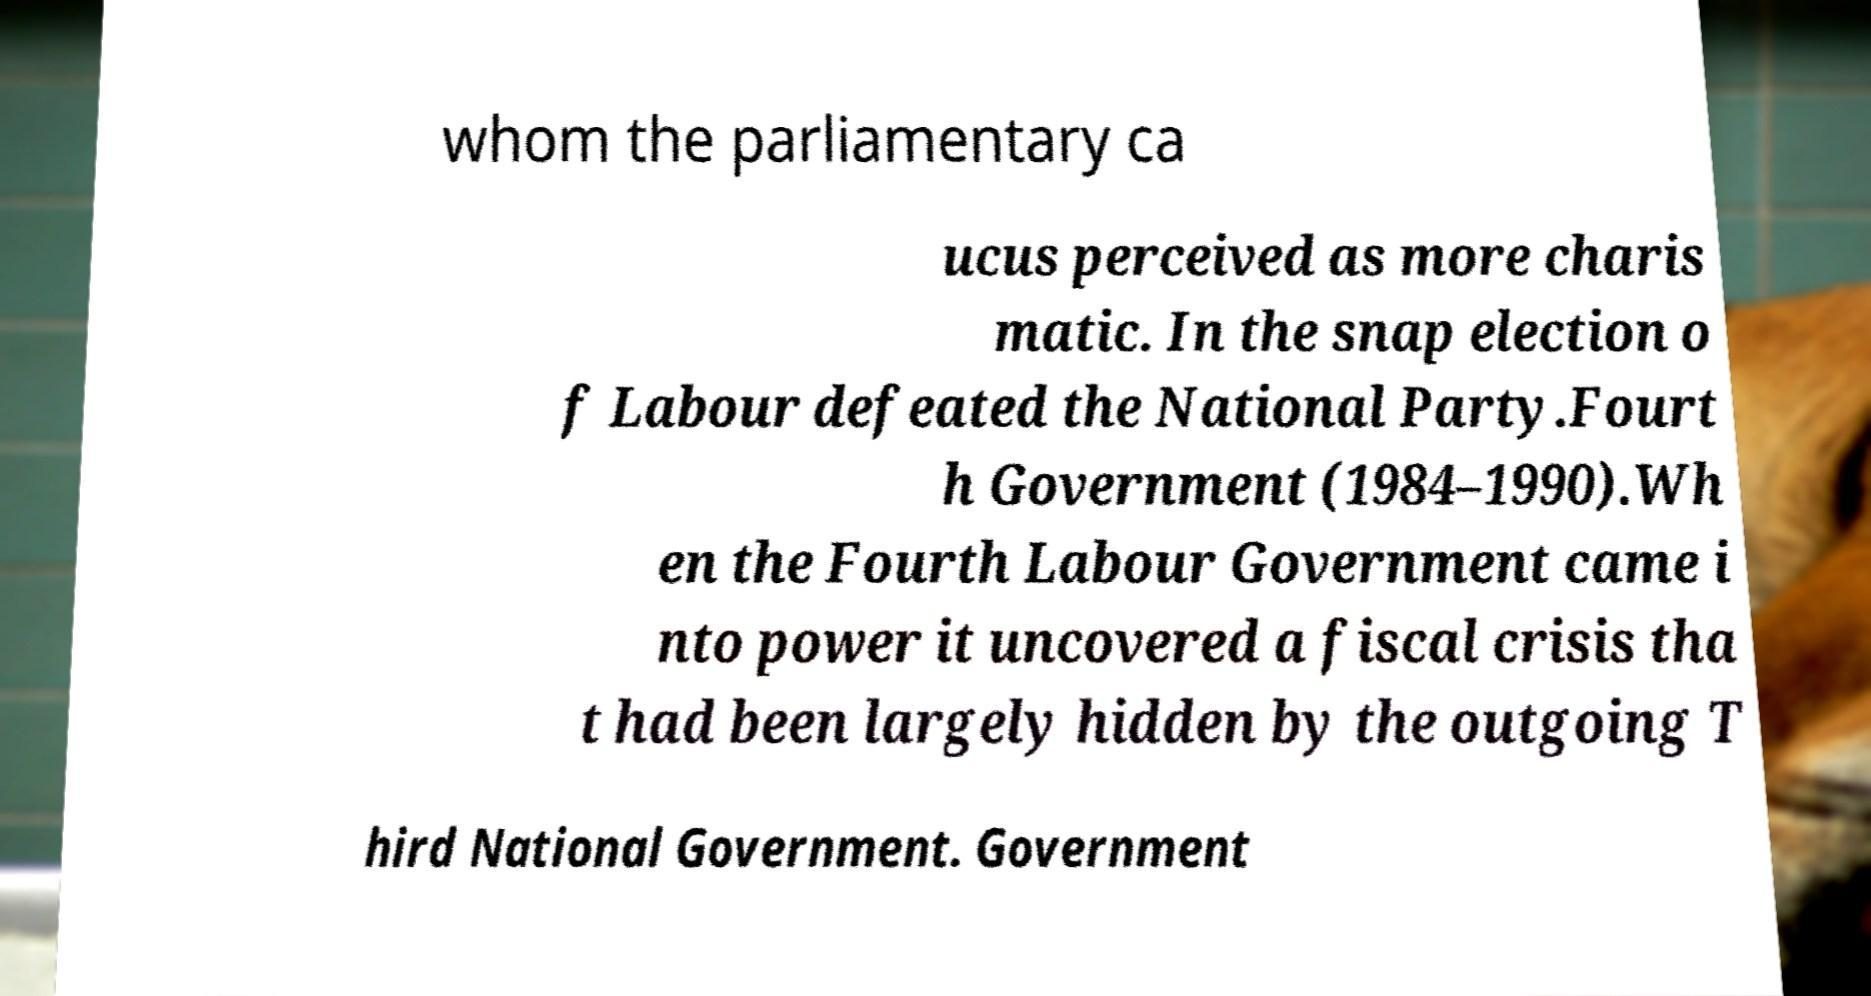What messages or text are displayed in this image? I need them in a readable, typed format. whom the parliamentary ca ucus perceived as more charis matic. In the snap election o f Labour defeated the National Party.Fourt h Government (1984–1990).Wh en the Fourth Labour Government came i nto power it uncovered a fiscal crisis tha t had been largely hidden by the outgoing T hird National Government. Government 